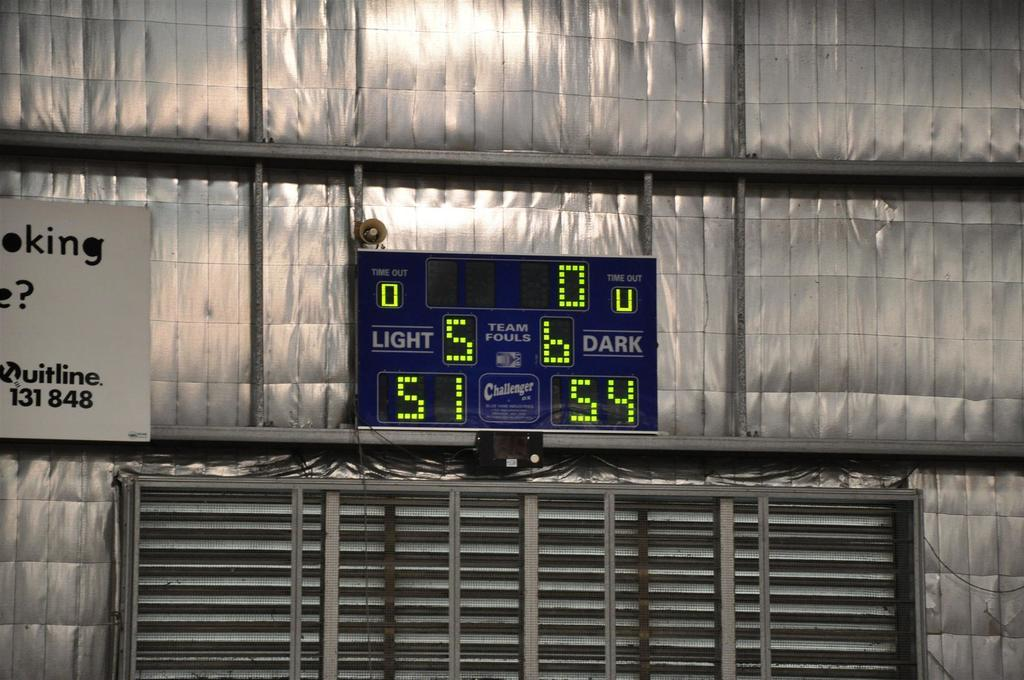<image>
Summarize the visual content of the image. Blue scoreboard showing the current score at 51-54. 